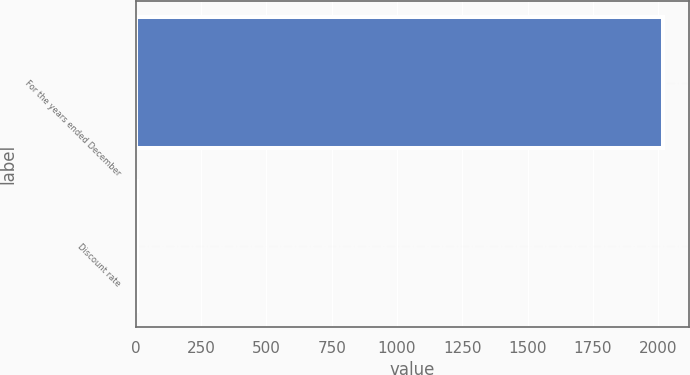<chart> <loc_0><loc_0><loc_500><loc_500><bar_chart><fcel>For the years ended December<fcel>Discount rate<nl><fcel>2017<fcel>3.8<nl></chart> 